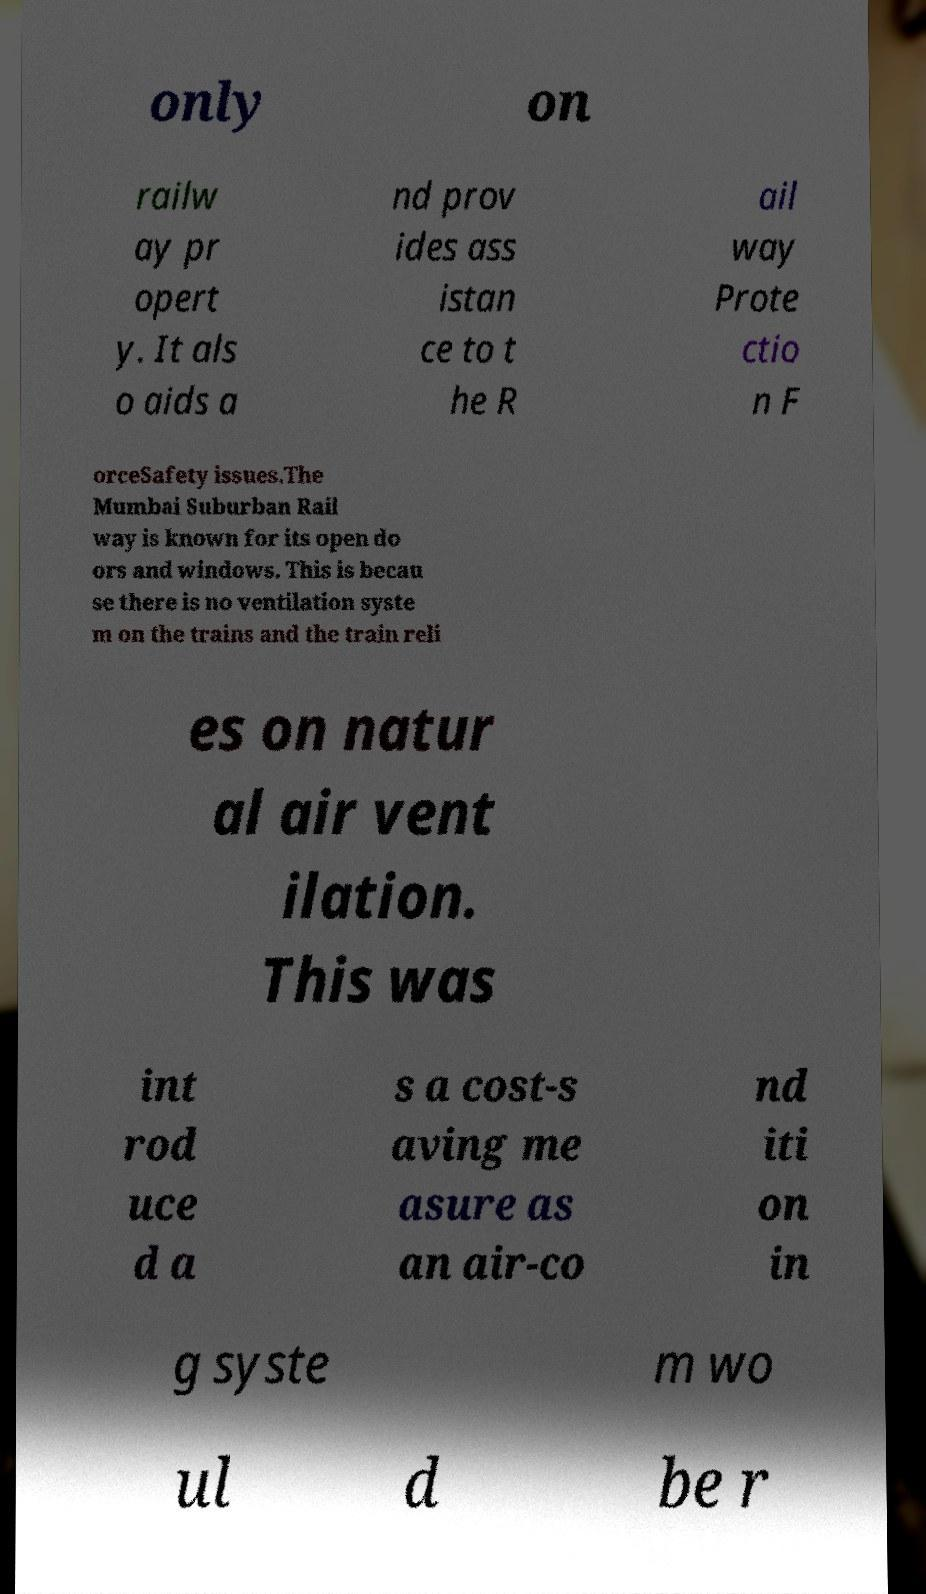Please identify and transcribe the text found in this image. only on railw ay pr opert y. It als o aids a nd prov ides ass istan ce to t he R ail way Prote ctio n F orceSafety issues.The Mumbai Suburban Rail way is known for its open do ors and windows. This is becau se there is no ventilation syste m on the trains and the train reli es on natur al air vent ilation. This was int rod uce d a s a cost-s aving me asure as an air-co nd iti on in g syste m wo ul d be r 